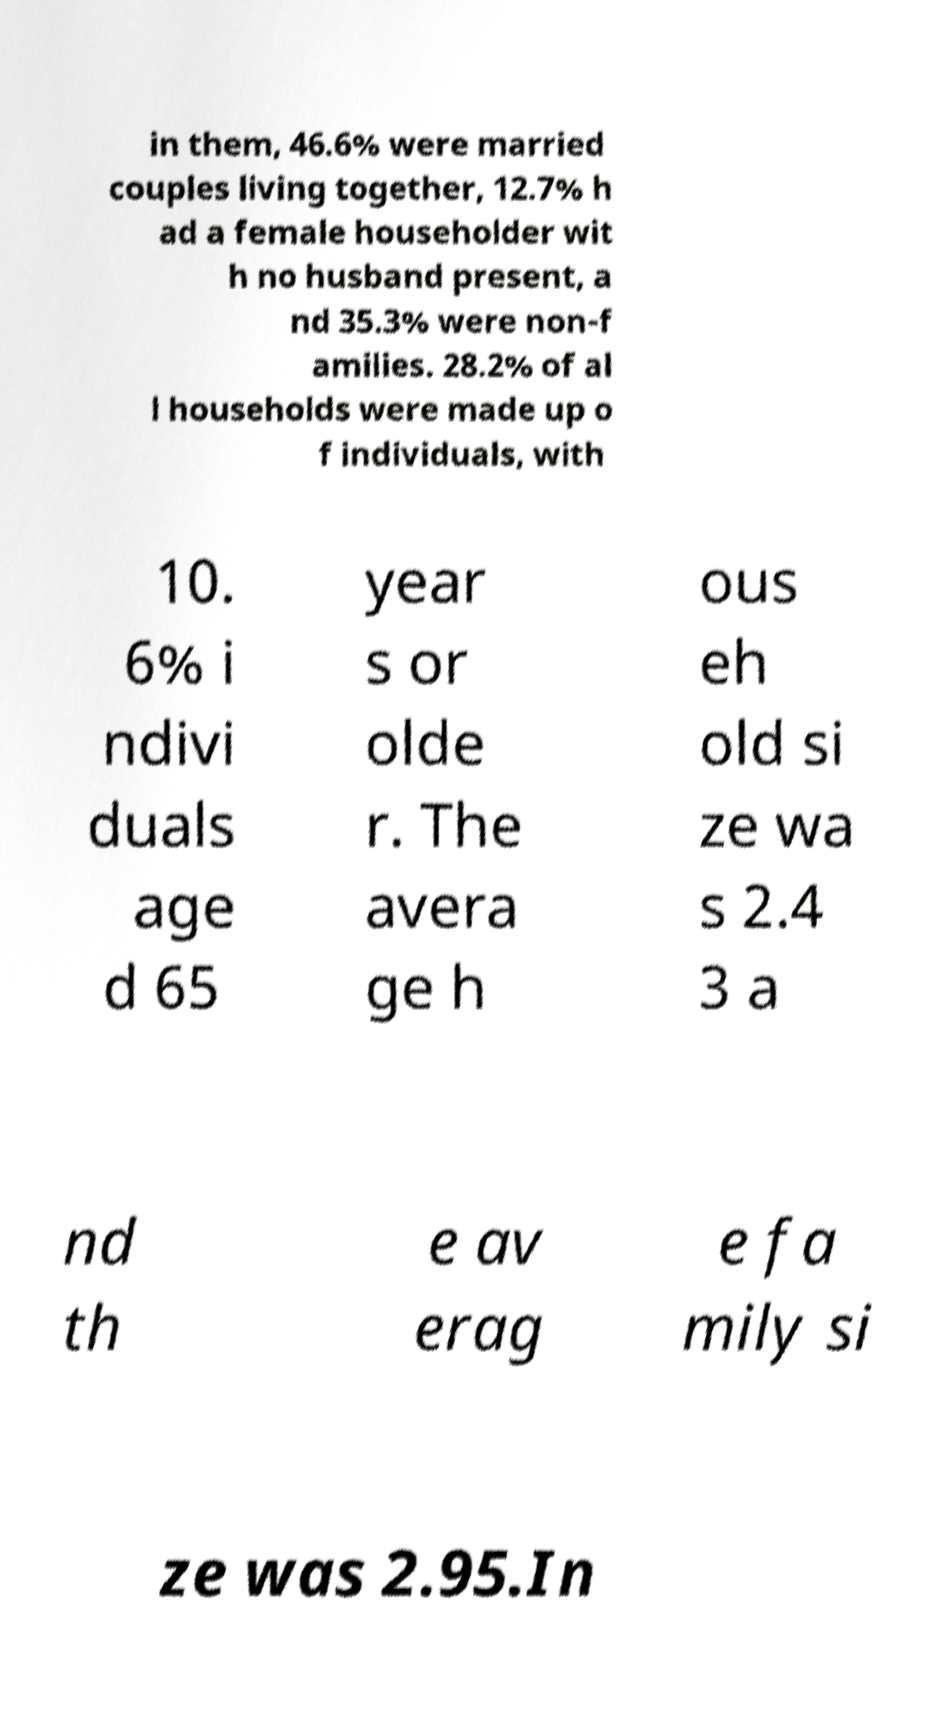Please identify and transcribe the text found in this image. in them, 46.6% were married couples living together, 12.7% h ad a female householder wit h no husband present, a nd 35.3% were non-f amilies. 28.2% of al l households were made up o f individuals, with 10. 6% i ndivi duals age d 65 year s or olde r. The avera ge h ous eh old si ze wa s 2.4 3 a nd th e av erag e fa mily si ze was 2.95.In 